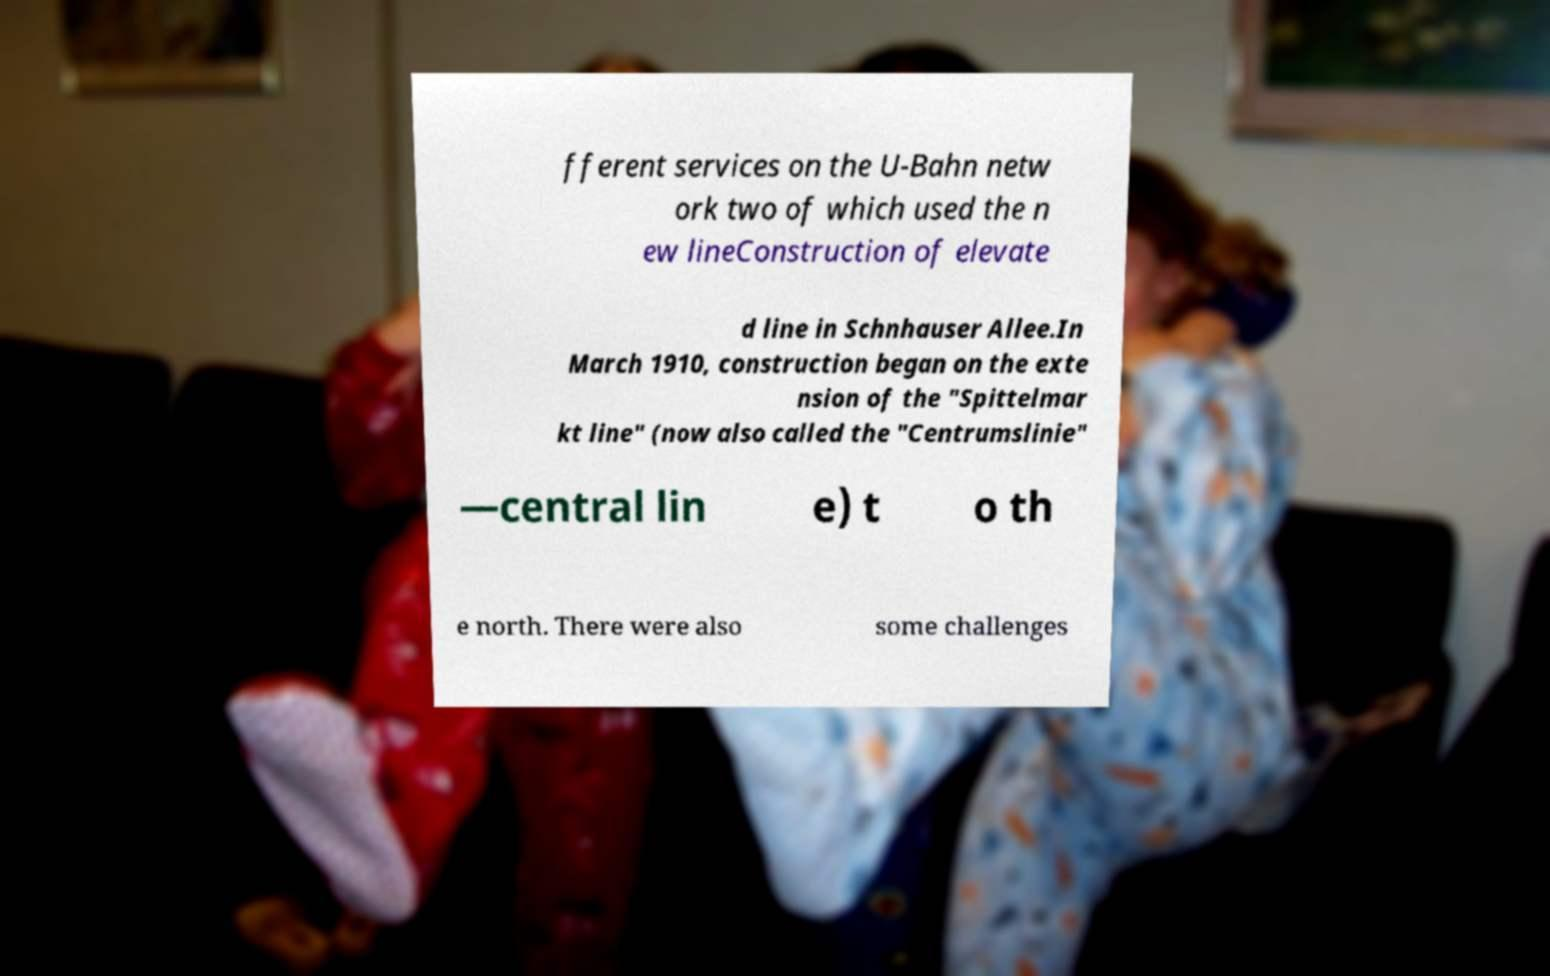For documentation purposes, I need the text within this image transcribed. Could you provide that? fferent services on the U-Bahn netw ork two of which used the n ew lineConstruction of elevate d line in Schnhauser Allee.In March 1910, construction began on the exte nsion of the "Spittelmar kt line" (now also called the "Centrumslinie" —central lin e) t o th e north. There were also some challenges 